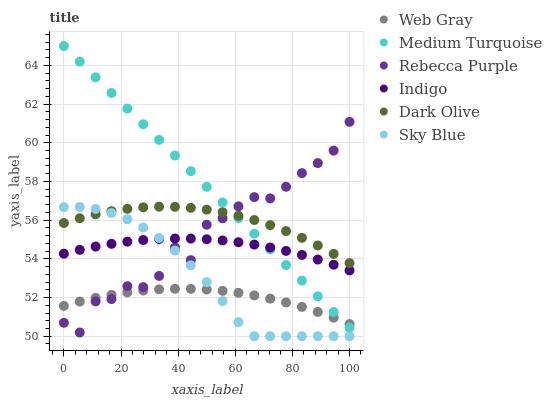Does Web Gray have the minimum area under the curve?
Answer yes or no. Yes. Does Medium Turquoise have the maximum area under the curve?
Answer yes or no. Yes. Does Indigo have the minimum area under the curve?
Answer yes or no. No. Does Indigo have the maximum area under the curve?
Answer yes or no. No. Is Medium Turquoise the smoothest?
Answer yes or no. Yes. Is Rebecca Purple the roughest?
Answer yes or no. Yes. Is Indigo the smoothest?
Answer yes or no. No. Is Indigo the roughest?
Answer yes or no. No. Does Sky Blue have the lowest value?
Answer yes or no. Yes. Does Indigo have the lowest value?
Answer yes or no. No. Does Medium Turquoise have the highest value?
Answer yes or no. Yes. Does Indigo have the highest value?
Answer yes or no. No. Is Indigo less than Dark Olive?
Answer yes or no. Yes. Is Dark Olive greater than Indigo?
Answer yes or no. Yes. Does Sky Blue intersect Dark Olive?
Answer yes or no. Yes. Is Sky Blue less than Dark Olive?
Answer yes or no. No. Is Sky Blue greater than Dark Olive?
Answer yes or no. No. Does Indigo intersect Dark Olive?
Answer yes or no. No. 